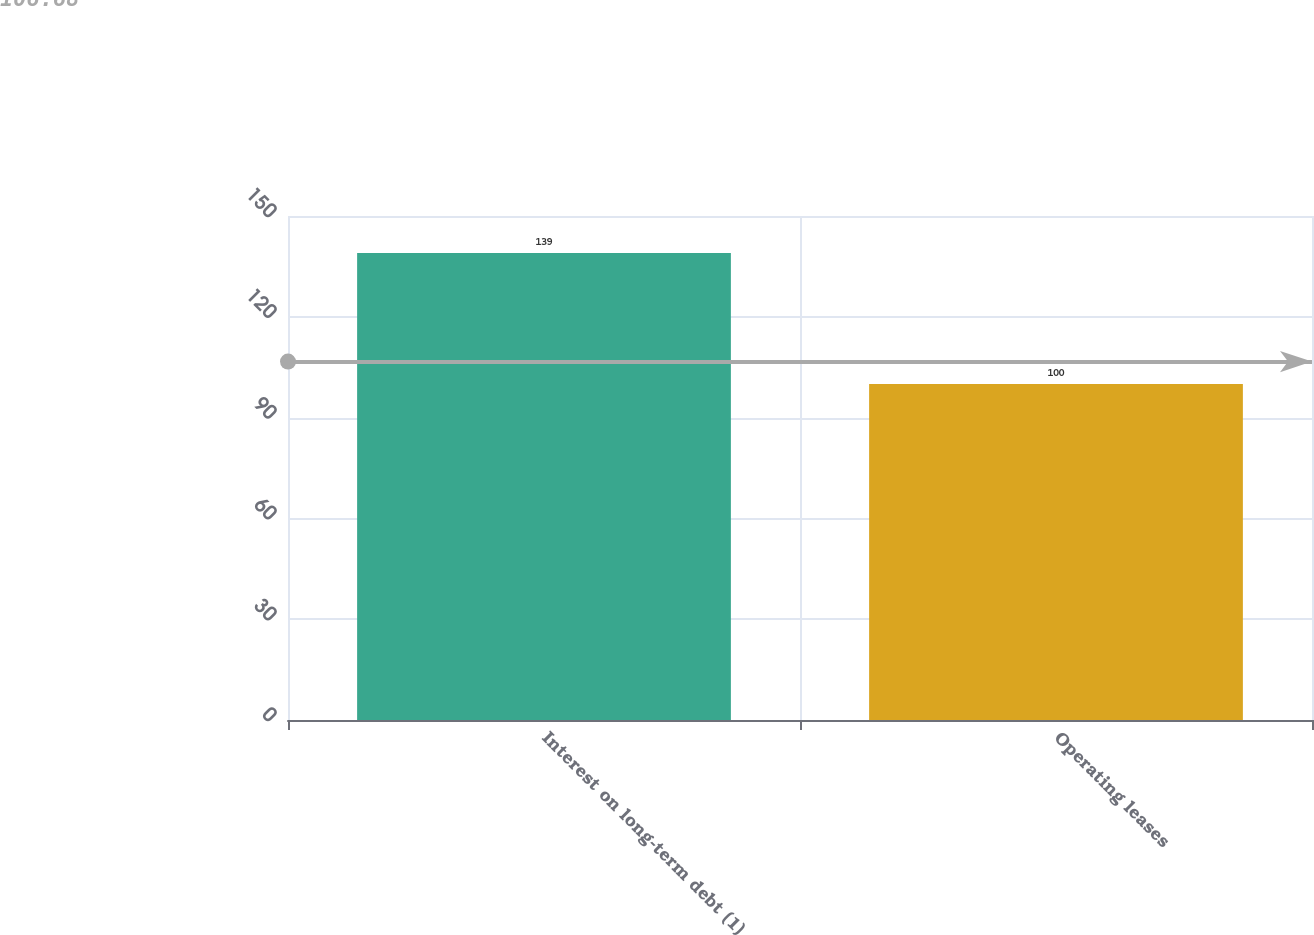<chart> <loc_0><loc_0><loc_500><loc_500><bar_chart><fcel>Interest on long-term debt (1)<fcel>Operating leases<nl><fcel>139<fcel>100<nl></chart> 